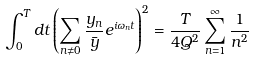<formula> <loc_0><loc_0><loc_500><loc_500>\int _ { 0 } ^ { T } d t \left ( \sum _ { n { \neq } 0 } \frac { y _ { n } } { \bar { y } } e ^ { i \omega _ { n } t } \right ) ^ { 2 } = \frac { T } { 4 Q ^ { 2 } } \sum _ { n = 1 } ^ { \infty } \frac { 1 } { n ^ { 2 } }</formula> 